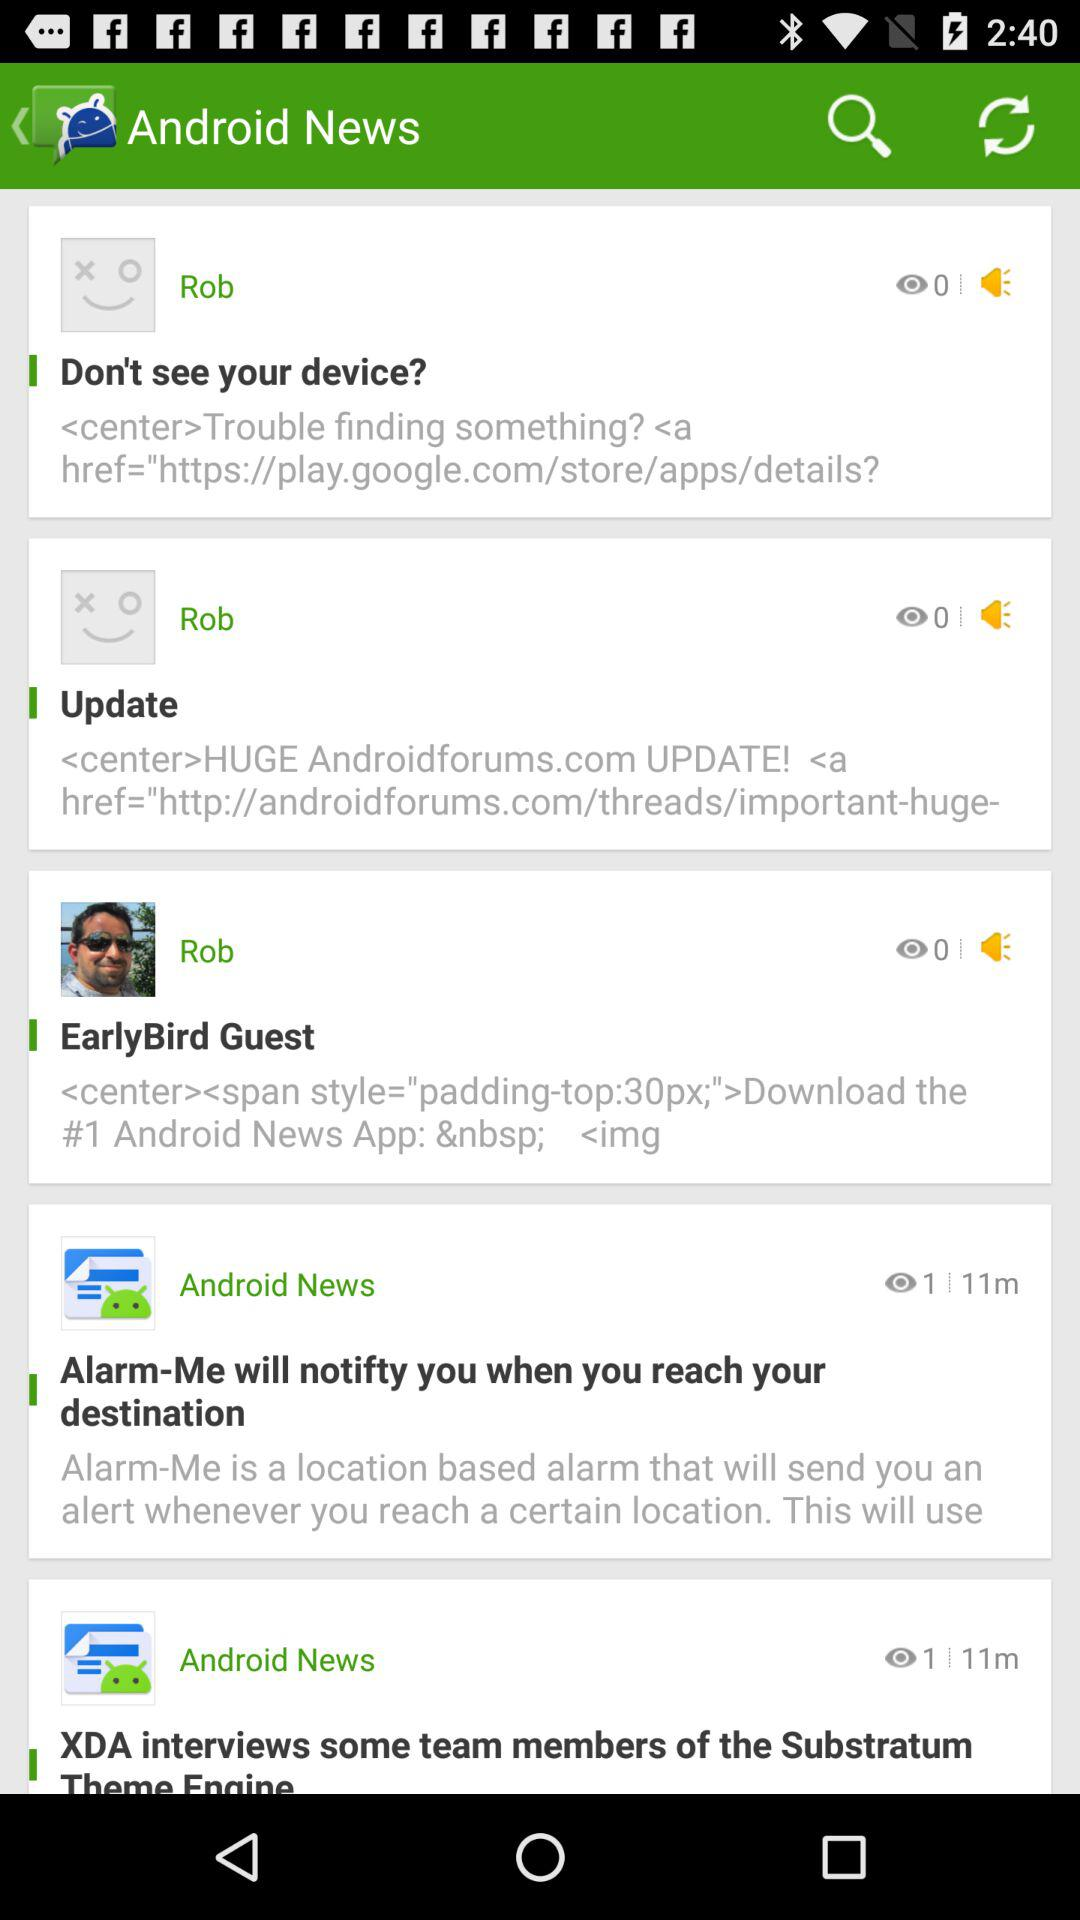When was the Android news about the "Alarm-Me" application posted? It was posted 11 minutes ago. 